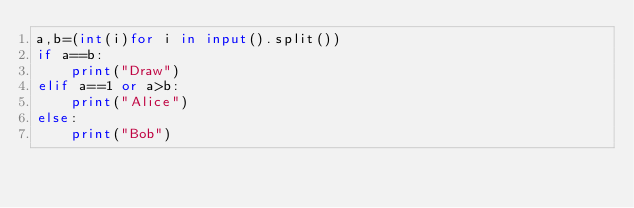<code> <loc_0><loc_0><loc_500><loc_500><_Python_>a,b=(int(i)for i in input().split())
if a==b:
    print("Draw")
elif a==1 or a>b:
    print("Alice")
else:
    print("Bob")
</code> 